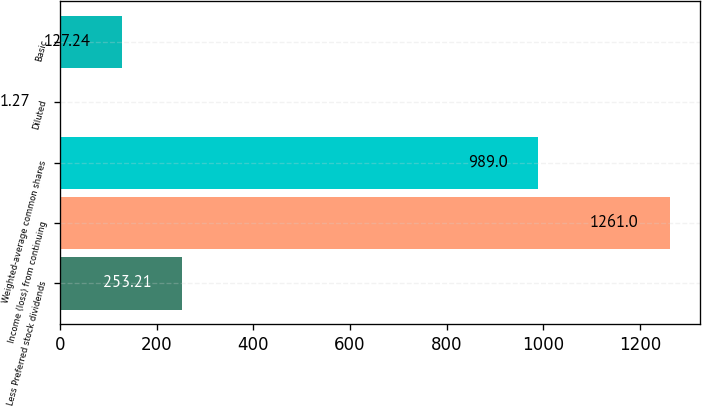Convert chart. <chart><loc_0><loc_0><loc_500><loc_500><bar_chart><fcel>Less Preferred stock dividends<fcel>Income (loss) from continuing<fcel>Weighted-average common shares<fcel>Diluted<fcel>Basic<nl><fcel>253.21<fcel>1261<fcel>989<fcel>1.27<fcel>127.24<nl></chart> 